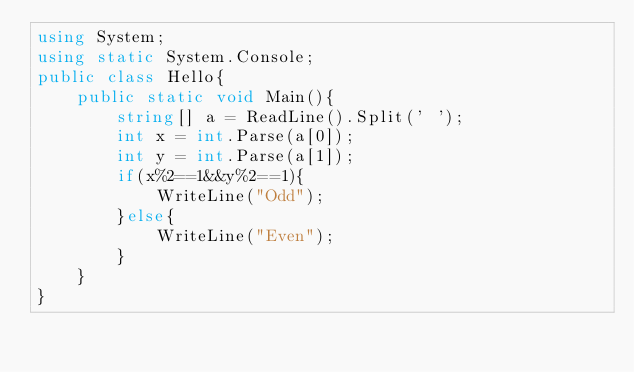<code> <loc_0><loc_0><loc_500><loc_500><_C#_>using System;
using static System.Console;
public class Hello{
    public static void Main(){
        string[] a = ReadLine().Split(' ');
        int x = int.Parse(a[0]);
        int y = int.Parse(a[1]);
        if(x%2==1&&y%2==1){
            WriteLine("Odd");
        }else{
            WriteLine("Even");
        }
    }
}
</code> 